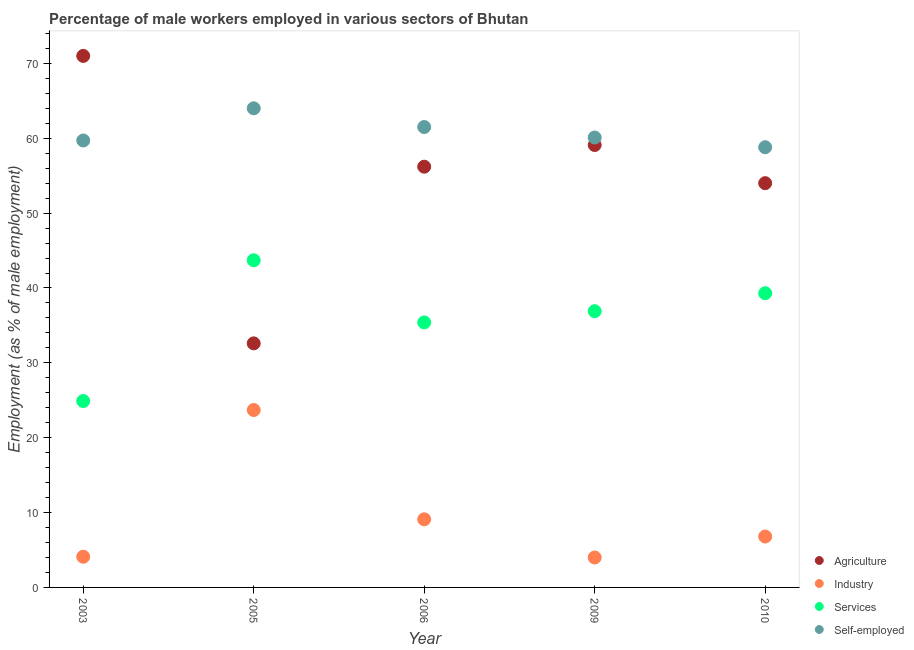What is the percentage of male workers in industry in 2005?
Provide a succinct answer. 23.7. Across all years, what is the maximum percentage of male workers in services?
Provide a short and direct response. 43.7. Across all years, what is the minimum percentage of male workers in agriculture?
Your answer should be compact. 32.6. In which year was the percentage of male workers in industry maximum?
Keep it short and to the point. 2005. What is the total percentage of self employed male workers in the graph?
Your answer should be very brief. 304.1. What is the difference between the percentage of male workers in services in 2009 and that in 2010?
Your answer should be very brief. -2.4. What is the difference between the percentage of male workers in services in 2006 and the percentage of male workers in industry in 2005?
Your answer should be compact. 11.7. What is the average percentage of male workers in industry per year?
Your answer should be compact. 9.54. In the year 2010, what is the difference between the percentage of male workers in agriculture and percentage of male workers in industry?
Your answer should be compact. 47.2. What is the ratio of the percentage of self employed male workers in 2003 to that in 2009?
Keep it short and to the point. 0.99. What is the difference between the highest and the second highest percentage of male workers in services?
Provide a short and direct response. 4.4. What is the difference between the highest and the lowest percentage of male workers in industry?
Provide a short and direct response. 19.7. Is it the case that in every year, the sum of the percentage of male workers in agriculture and percentage of male workers in industry is greater than the percentage of male workers in services?
Give a very brief answer. Yes. Does the percentage of male workers in industry monotonically increase over the years?
Your answer should be compact. No. Is the percentage of self employed male workers strictly less than the percentage of male workers in services over the years?
Provide a short and direct response. No. How many dotlines are there?
Offer a terse response. 4. Are the values on the major ticks of Y-axis written in scientific E-notation?
Keep it short and to the point. No. Where does the legend appear in the graph?
Ensure brevity in your answer.  Bottom right. What is the title of the graph?
Your answer should be very brief. Percentage of male workers employed in various sectors of Bhutan. Does "Self-employed" appear as one of the legend labels in the graph?
Ensure brevity in your answer.  Yes. What is the label or title of the Y-axis?
Give a very brief answer. Employment (as % of male employment). What is the Employment (as % of male employment) of Agriculture in 2003?
Offer a terse response. 71. What is the Employment (as % of male employment) in Industry in 2003?
Your response must be concise. 4.1. What is the Employment (as % of male employment) of Services in 2003?
Give a very brief answer. 24.9. What is the Employment (as % of male employment) of Self-employed in 2003?
Make the answer very short. 59.7. What is the Employment (as % of male employment) in Agriculture in 2005?
Keep it short and to the point. 32.6. What is the Employment (as % of male employment) in Industry in 2005?
Offer a terse response. 23.7. What is the Employment (as % of male employment) of Services in 2005?
Offer a terse response. 43.7. What is the Employment (as % of male employment) in Agriculture in 2006?
Make the answer very short. 56.2. What is the Employment (as % of male employment) of Industry in 2006?
Provide a short and direct response. 9.1. What is the Employment (as % of male employment) in Services in 2006?
Make the answer very short. 35.4. What is the Employment (as % of male employment) in Self-employed in 2006?
Your answer should be very brief. 61.5. What is the Employment (as % of male employment) of Agriculture in 2009?
Your answer should be compact. 59.1. What is the Employment (as % of male employment) of Services in 2009?
Keep it short and to the point. 36.9. What is the Employment (as % of male employment) of Self-employed in 2009?
Offer a terse response. 60.1. What is the Employment (as % of male employment) in Agriculture in 2010?
Offer a very short reply. 54. What is the Employment (as % of male employment) in Industry in 2010?
Offer a very short reply. 6.8. What is the Employment (as % of male employment) in Services in 2010?
Ensure brevity in your answer.  39.3. What is the Employment (as % of male employment) in Self-employed in 2010?
Provide a succinct answer. 58.8. Across all years, what is the maximum Employment (as % of male employment) of Agriculture?
Offer a terse response. 71. Across all years, what is the maximum Employment (as % of male employment) of Industry?
Make the answer very short. 23.7. Across all years, what is the maximum Employment (as % of male employment) of Services?
Keep it short and to the point. 43.7. Across all years, what is the maximum Employment (as % of male employment) of Self-employed?
Offer a very short reply. 64. Across all years, what is the minimum Employment (as % of male employment) of Agriculture?
Offer a very short reply. 32.6. Across all years, what is the minimum Employment (as % of male employment) of Industry?
Keep it short and to the point. 4. Across all years, what is the minimum Employment (as % of male employment) in Services?
Your answer should be very brief. 24.9. Across all years, what is the minimum Employment (as % of male employment) in Self-employed?
Your answer should be very brief. 58.8. What is the total Employment (as % of male employment) in Agriculture in the graph?
Offer a very short reply. 272.9. What is the total Employment (as % of male employment) of Industry in the graph?
Keep it short and to the point. 47.7. What is the total Employment (as % of male employment) in Services in the graph?
Your answer should be very brief. 180.2. What is the total Employment (as % of male employment) in Self-employed in the graph?
Offer a terse response. 304.1. What is the difference between the Employment (as % of male employment) in Agriculture in 2003 and that in 2005?
Provide a short and direct response. 38.4. What is the difference between the Employment (as % of male employment) in Industry in 2003 and that in 2005?
Make the answer very short. -19.6. What is the difference between the Employment (as % of male employment) of Services in 2003 and that in 2005?
Provide a short and direct response. -18.8. What is the difference between the Employment (as % of male employment) of Agriculture in 2003 and that in 2006?
Provide a short and direct response. 14.8. What is the difference between the Employment (as % of male employment) of Self-employed in 2003 and that in 2006?
Your answer should be compact. -1.8. What is the difference between the Employment (as % of male employment) of Self-employed in 2003 and that in 2009?
Make the answer very short. -0.4. What is the difference between the Employment (as % of male employment) of Industry in 2003 and that in 2010?
Make the answer very short. -2.7. What is the difference between the Employment (as % of male employment) of Services in 2003 and that in 2010?
Make the answer very short. -14.4. What is the difference between the Employment (as % of male employment) in Agriculture in 2005 and that in 2006?
Provide a short and direct response. -23.6. What is the difference between the Employment (as % of male employment) in Industry in 2005 and that in 2006?
Offer a terse response. 14.6. What is the difference between the Employment (as % of male employment) of Agriculture in 2005 and that in 2009?
Offer a terse response. -26.5. What is the difference between the Employment (as % of male employment) in Industry in 2005 and that in 2009?
Keep it short and to the point. 19.7. What is the difference between the Employment (as % of male employment) of Services in 2005 and that in 2009?
Make the answer very short. 6.8. What is the difference between the Employment (as % of male employment) in Self-employed in 2005 and that in 2009?
Your answer should be compact. 3.9. What is the difference between the Employment (as % of male employment) in Agriculture in 2005 and that in 2010?
Make the answer very short. -21.4. What is the difference between the Employment (as % of male employment) of Industry in 2005 and that in 2010?
Your answer should be very brief. 16.9. What is the difference between the Employment (as % of male employment) in Self-employed in 2005 and that in 2010?
Ensure brevity in your answer.  5.2. What is the difference between the Employment (as % of male employment) in Industry in 2006 and that in 2009?
Your answer should be compact. 5.1. What is the difference between the Employment (as % of male employment) in Services in 2006 and that in 2009?
Keep it short and to the point. -1.5. What is the difference between the Employment (as % of male employment) in Agriculture in 2006 and that in 2010?
Make the answer very short. 2.2. What is the difference between the Employment (as % of male employment) of Services in 2006 and that in 2010?
Give a very brief answer. -3.9. What is the difference between the Employment (as % of male employment) of Agriculture in 2009 and that in 2010?
Offer a terse response. 5.1. What is the difference between the Employment (as % of male employment) in Industry in 2009 and that in 2010?
Keep it short and to the point. -2.8. What is the difference between the Employment (as % of male employment) of Services in 2009 and that in 2010?
Your response must be concise. -2.4. What is the difference between the Employment (as % of male employment) in Self-employed in 2009 and that in 2010?
Your answer should be compact. 1.3. What is the difference between the Employment (as % of male employment) of Agriculture in 2003 and the Employment (as % of male employment) of Industry in 2005?
Ensure brevity in your answer.  47.3. What is the difference between the Employment (as % of male employment) in Agriculture in 2003 and the Employment (as % of male employment) in Services in 2005?
Your answer should be compact. 27.3. What is the difference between the Employment (as % of male employment) of Industry in 2003 and the Employment (as % of male employment) of Services in 2005?
Give a very brief answer. -39.6. What is the difference between the Employment (as % of male employment) in Industry in 2003 and the Employment (as % of male employment) in Self-employed in 2005?
Make the answer very short. -59.9. What is the difference between the Employment (as % of male employment) of Services in 2003 and the Employment (as % of male employment) of Self-employed in 2005?
Provide a succinct answer. -39.1. What is the difference between the Employment (as % of male employment) of Agriculture in 2003 and the Employment (as % of male employment) of Industry in 2006?
Your answer should be compact. 61.9. What is the difference between the Employment (as % of male employment) in Agriculture in 2003 and the Employment (as % of male employment) in Services in 2006?
Your answer should be very brief. 35.6. What is the difference between the Employment (as % of male employment) in Agriculture in 2003 and the Employment (as % of male employment) in Self-employed in 2006?
Offer a terse response. 9.5. What is the difference between the Employment (as % of male employment) in Industry in 2003 and the Employment (as % of male employment) in Services in 2006?
Your response must be concise. -31.3. What is the difference between the Employment (as % of male employment) in Industry in 2003 and the Employment (as % of male employment) in Self-employed in 2006?
Your answer should be very brief. -57.4. What is the difference between the Employment (as % of male employment) of Services in 2003 and the Employment (as % of male employment) of Self-employed in 2006?
Offer a terse response. -36.6. What is the difference between the Employment (as % of male employment) of Agriculture in 2003 and the Employment (as % of male employment) of Services in 2009?
Make the answer very short. 34.1. What is the difference between the Employment (as % of male employment) in Agriculture in 2003 and the Employment (as % of male employment) in Self-employed in 2009?
Offer a terse response. 10.9. What is the difference between the Employment (as % of male employment) of Industry in 2003 and the Employment (as % of male employment) of Services in 2009?
Offer a terse response. -32.8. What is the difference between the Employment (as % of male employment) in Industry in 2003 and the Employment (as % of male employment) in Self-employed in 2009?
Your response must be concise. -56. What is the difference between the Employment (as % of male employment) in Services in 2003 and the Employment (as % of male employment) in Self-employed in 2009?
Offer a terse response. -35.2. What is the difference between the Employment (as % of male employment) of Agriculture in 2003 and the Employment (as % of male employment) of Industry in 2010?
Your answer should be compact. 64.2. What is the difference between the Employment (as % of male employment) in Agriculture in 2003 and the Employment (as % of male employment) in Services in 2010?
Your answer should be compact. 31.7. What is the difference between the Employment (as % of male employment) in Agriculture in 2003 and the Employment (as % of male employment) in Self-employed in 2010?
Make the answer very short. 12.2. What is the difference between the Employment (as % of male employment) of Industry in 2003 and the Employment (as % of male employment) of Services in 2010?
Offer a very short reply. -35.2. What is the difference between the Employment (as % of male employment) in Industry in 2003 and the Employment (as % of male employment) in Self-employed in 2010?
Your response must be concise. -54.7. What is the difference between the Employment (as % of male employment) of Services in 2003 and the Employment (as % of male employment) of Self-employed in 2010?
Your answer should be compact. -33.9. What is the difference between the Employment (as % of male employment) in Agriculture in 2005 and the Employment (as % of male employment) in Industry in 2006?
Your answer should be very brief. 23.5. What is the difference between the Employment (as % of male employment) of Agriculture in 2005 and the Employment (as % of male employment) of Self-employed in 2006?
Provide a succinct answer. -28.9. What is the difference between the Employment (as % of male employment) in Industry in 2005 and the Employment (as % of male employment) in Services in 2006?
Offer a very short reply. -11.7. What is the difference between the Employment (as % of male employment) of Industry in 2005 and the Employment (as % of male employment) of Self-employed in 2006?
Offer a very short reply. -37.8. What is the difference between the Employment (as % of male employment) in Services in 2005 and the Employment (as % of male employment) in Self-employed in 2006?
Your answer should be compact. -17.8. What is the difference between the Employment (as % of male employment) of Agriculture in 2005 and the Employment (as % of male employment) of Industry in 2009?
Keep it short and to the point. 28.6. What is the difference between the Employment (as % of male employment) in Agriculture in 2005 and the Employment (as % of male employment) in Self-employed in 2009?
Give a very brief answer. -27.5. What is the difference between the Employment (as % of male employment) in Industry in 2005 and the Employment (as % of male employment) in Services in 2009?
Give a very brief answer. -13.2. What is the difference between the Employment (as % of male employment) in Industry in 2005 and the Employment (as % of male employment) in Self-employed in 2009?
Your response must be concise. -36.4. What is the difference between the Employment (as % of male employment) in Services in 2005 and the Employment (as % of male employment) in Self-employed in 2009?
Offer a terse response. -16.4. What is the difference between the Employment (as % of male employment) in Agriculture in 2005 and the Employment (as % of male employment) in Industry in 2010?
Ensure brevity in your answer.  25.8. What is the difference between the Employment (as % of male employment) of Agriculture in 2005 and the Employment (as % of male employment) of Self-employed in 2010?
Offer a terse response. -26.2. What is the difference between the Employment (as % of male employment) of Industry in 2005 and the Employment (as % of male employment) of Services in 2010?
Ensure brevity in your answer.  -15.6. What is the difference between the Employment (as % of male employment) in Industry in 2005 and the Employment (as % of male employment) in Self-employed in 2010?
Give a very brief answer. -35.1. What is the difference between the Employment (as % of male employment) in Services in 2005 and the Employment (as % of male employment) in Self-employed in 2010?
Offer a terse response. -15.1. What is the difference between the Employment (as % of male employment) in Agriculture in 2006 and the Employment (as % of male employment) in Industry in 2009?
Ensure brevity in your answer.  52.2. What is the difference between the Employment (as % of male employment) of Agriculture in 2006 and the Employment (as % of male employment) of Services in 2009?
Offer a terse response. 19.3. What is the difference between the Employment (as % of male employment) of Agriculture in 2006 and the Employment (as % of male employment) of Self-employed in 2009?
Your answer should be compact. -3.9. What is the difference between the Employment (as % of male employment) of Industry in 2006 and the Employment (as % of male employment) of Services in 2009?
Give a very brief answer. -27.8. What is the difference between the Employment (as % of male employment) in Industry in 2006 and the Employment (as % of male employment) in Self-employed in 2009?
Ensure brevity in your answer.  -51. What is the difference between the Employment (as % of male employment) in Services in 2006 and the Employment (as % of male employment) in Self-employed in 2009?
Offer a very short reply. -24.7. What is the difference between the Employment (as % of male employment) in Agriculture in 2006 and the Employment (as % of male employment) in Industry in 2010?
Your response must be concise. 49.4. What is the difference between the Employment (as % of male employment) in Agriculture in 2006 and the Employment (as % of male employment) in Services in 2010?
Your answer should be compact. 16.9. What is the difference between the Employment (as % of male employment) of Industry in 2006 and the Employment (as % of male employment) of Services in 2010?
Your response must be concise. -30.2. What is the difference between the Employment (as % of male employment) in Industry in 2006 and the Employment (as % of male employment) in Self-employed in 2010?
Your answer should be compact. -49.7. What is the difference between the Employment (as % of male employment) of Services in 2006 and the Employment (as % of male employment) of Self-employed in 2010?
Provide a short and direct response. -23.4. What is the difference between the Employment (as % of male employment) of Agriculture in 2009 and the Employment (as % of male employment) of Industry in 2010?
Offer a terse response. 52.3. What is the difference between the Employment (as % of male employment) of Agriculture in 2009 and the Employment (as % of male employment) of Services in 2010?
Offer a terse response. 19.8. What is the difference between the Employment (as % of male employment) of Industry in 2009 and the Employment (as % of male employment) of Services in 2010?
Your response must be concise. -35.3. What is the difference between the Employment (as % of male employment) of Industry in 2009 and the Employment (as % of male employment) of Self-employed in 2010?
Give a very brief answer. -54.8. What is the difference between the Employment (as % of male employment) of Services in 2009 and the Employment (as % of male employment) of Self-employed in 2010?
Your answer should be compact. -21.9. What is the average Employment (as % of male employment) of Agriculture per year?
Offer a very short reply. 54.58. What is the average Employment (as % of male employment) in Industry per year?
Keep it short and to the point. 9.54. What is the average Employment (as % of male employment) of Services per year?
Ensure brevity in your answer.  36.04. What is the average Employment (as % of male employment) in Self-employed per year?
Keep it short and to the point. 60.82. In the year 2003, what is the difference between the Employment (as % of male employment) in Agriculture and Employment (as % of male employment) in Industry?
Offer a terse response. 66.9. In the year 2003, what is the difference between the Employment (as % of male employment) of Agriculture and Employment (as % of male employment) of Services?
Offer a terse response. 46.1. In the year 2003, what is the difference between the Employment (as % of male employment) in Agriculture and Employment (as % of male employment) in Self-employed?
Offer a terse response. 11.3. In the year 2003, what is the difference between the Employment (as % of male employment) of Industry and Employment (as % of male employment) of Services?
Provide a succinct answer. -20.8. In the year 2003, what is the difference between the Employment (as % of male employment) in Industry and Employment (as % of male employment) in Self-employed?
Keep it short and to the point. -55.6. In the year 2003, what is the difference between the Employment (as % of male employment) of Services and Employment (as % of male employment) of Self-employed?
Keep it short and to the point. -34.8. In the year 2005, what is the difference between the Employment (as % of male employment) of Agriculture and Employment (as % of male employment) of Self-employed?
Your answer should be very brief. -31.4. In the year 2005, what is the difference between the Employment (as % of male employment) of Industry and Employment (as % of male employment) of Self-employed?
Provide a short and direct response. -40.3. In the year 2005, what is the difference between the Employment (as % of male employment) of Services and Employment (as % of male employment) of Self-employed?
Make the answer very short. -20.3. In the year 2006, what is the difference between the Employment (as % of male employment) in Agriculture and Employment (as % of male employment) in Industry?
Ensure brevity in your answer.  47.1. In the year 2006, what is the difference between the Employment (as % of male employment) in Agriculture and Employment (as % of male employment) in Services?
Offer a very short reply. 20.8. In the year 2006, what is the difference between the Employment (as % of male employment) in Agriculture and Employment (as % of male employment) in Self-employed?
Keep it short and to the point. -5.3. In the year 2006, what is the difference between the Employment (as % of male employment) in Industry and Employment (as % of male employment) in Services?
Give a very brief answer. -26.3. In the year 2006, what is the difference between the Employment (as % of male employment) of Industry and Employment (as % of male employment) of Self-employed?
Give a very brief answer. -52.4. In the year 2006, what is the difference between the Employment (as % of male employment) in Services and Employment (as % of male employment) in Self-employed?
Ensure brevity in your answer.  -26.1. In the year 2009, what is the difference between the Employment (as % of male employment) of Agriculture and Employment (as % of male employment) of Industry?
Ensure brevity in your answer.  55.1. In the year 2009, what is the difference between the Employment (as % of male employment) in Industry and Employment (as % of male employment) in Services?
Your answer should be compact. -32.9. In the year 2009, what is the difference between the Employment (as % of male employment) in Industry and Employment (as % of male employment) in Self-employed?
Give a very brief answer. -56.1. In the year 2009, what is the difference between the Employment (as % of male employment) in Services and Employment (as % of male employment) in Self-employed?
Give a very brief answer. -23.2. In the year 2010, what is the difference between the Employment (as % of male employment) of Agriculture and Employment (as % of male employment) of Industry?
Your answer should be very brief. 47.2. In the year 2010, what is the difference between the Employment (as % of male employment) in Industry and Employment (as % of male employment) in Services?
Make the answer very short. -32.5. In the year 2010, what is the difference between the Employment (as % of male employment) in Industry and Employment (as % of male employment) in Self-employed?
Keep it short and to the point. -52. In the year 2010, what is the difference between the Employment (as % of male employment) in Services and Employment (as % of male employment) in Self-employed?
Ensure brevity in your answer.  -19.5. What is the ratio of the Employment (as % of male employment) in Agriculture in 2003 to that in 2005?
Provide a succinct answer. 2.18. What is the ratio of the Employment (as % of male employment) in Industry in 2003 to that in 2005?
Give a very brief answer. 0.17. What is the ratio of the Employment (as % of male employment) of Services in 2003 to that in 2005?
Offer a very short reply. 0.57. What is the ratio of the Employment (as % of male employment) in Self-employed in 2003 to that in 2005?
Make the answer very short. 0.93. What is the ratio of the Employment (as % of male employment) of Agriculture in 2003 to that in 2006?
Offer a very short reply. 1.26. What is the ratio of the Employment (as % of male employment) of Industry in 2003 to that in 2006?
Your response must be concise. 0.45. What is the ratio of the Employment (as % of male employment) of Services in 2003 to that in 2006?
Keep it short and to the point. 0.7. What is the ratio of the Employment (as % of male employment) in Self-employed in 2003 to that in 2006?
Your response must be concise. 0.97. What is the ratio of the Employment (as % of male employment) in Agriculture in 2003 to that in 2009?
Give a very brief answer. 1.2. What is the ratio of the Employment (as % of male employment) of Services in 2003 to that in 2009?
Your answer should be very brief. 0.67. What is the ratio of the Employment (as % of male employment) of Self-employed in 2003 to that in 2009?
Ensure brevity in your answer.  0.99. What is the ratio of the Employment (as % of male employment) in Agriculture in 2003 to that in 2010?
Make the answer very short. 1.31. What is the ratio of the Employment (as % of male employment) of Industry in 2003 to that in 2010?
Your answer should be very brief. 0.6. What is the ratio of the Employment (as % of male employment) of Services in 2003 to that in 2010?
Offer a terse response. 0.63. What is the ratio of the Employment (as % of male employment) in Self-employed in 2003 to that in 2010?
Make the answer very short. 1.02. What is the ratio of the Employment (as % of male employment) in Agriculture in 2005 to that in 2006?
Provide a short and direct response. 0.58. What is the ratio of the Employment (as % of male employment) of Industry in 2005 to that in 2006?
Provide a succinct answer. 2.6. What is the ratio of the Employment (as % of male employment) of Services in 2005 to that in 2006?
Your response must be concise. 1.23. What is the ratio of the Employment (as % of male employment) in Self-employed in 2005 to that in 2006?
Keep it short and to the point. 1.04. What is the ratio of the Employment (as % of male employment) of Agriculture in 2005 to that in 2009?
Your answer should be compact. 0.55. What is the ratio of the Employment (as % of male employment) of Industry in 2005 to that in 2009?
Your answer should be very brief. 5.92. What is the ratio of the Employment (as % of male employment) of Services in 2005 to that in 2009?
Your answer should be very brief. 1.18. What is the ratio of the Employment (as % of male employment) in Self-employed in 2005 to that in 2009?
Offer a terse response. 1.06. What is the ratio of the Employment (as % of male employment) in Agriculture in 2005 to that in 2010?
Offer a very short reply. 0.6. What is the ratio of the Employment (as % of male employment) of Industry in 2005 to that in 2010?
Ensure brevity in your answer.  3.49. What is the ratio of the Employment (as % of male employment) of Services in 2005 to that in 2010?
Provide a short and direct response. 1.11. What is the ratio of the Employment (as % of male employment) in Self-employed in 2005 to that in 2010?
Ensure brevity in your answer.  1.09. What is the ratio of the Employment (as % of male employment) of Agriculture in 2006 to that in 2009?
Make the answer very short. 0.95. What is the ratio of the Employment (as % of male employment) in Industry in 2006 to that in 2009?
Keep it short and to the point. 2.27. What is the ratio of the Employment (as % of male employment) of Services in 2006 to that in 2009?
Your response must be concise. 0.96. What is the ratio of the Employment (as % of male employment) of Self-employed in 2006 to that in 2009?
Give a very brief answer. 1.02. What is the ratio of the Employment (as % of male employment) in Agriculture in 2006 to that in 2010?
Make the answer very short. 1.04. What is the ratio of the Employment (as % of male employment) of Industry in 2006 to that in 2010?
Provide a short and direct response. 1.34. What is the ratio of the Employment (as % of male employment) of Services in 2006 to that in 2010?
Your answer should be compact. 0.9. What is the ratio of the Employment (as % of male employment) of Self-employed in 2006 to that in 2010?
Provide a succinct answer. 1.05. What is the ratio of the Employment (as % of male employment) in Agriculture in 2009 to that in 2010?
Provide a succinct answer. 1.09. What is the ratio of the Employment (as % of male employment) of Industry in 2009 to that in 2010?
Your answer should be compact. 0.59. What is the ratio of the Employment (as % of male employment) of Services in 2009 to that in 2010?
Your answer should be very brief. 0.94. What is the ratio of the Employment (as % of male employment) in Self-employed in 2009 to that in 2010?
Your answer should be very brief. 1.02. What is the difference between the highest and the lowest Employment (as % of male employment) of Agriculture?
Your answer should be compact. 38.4. What is the difference between the highest and the lowest Employment (as % of male employment) in Industry?
Your answer should be very brief. 19.7. What is the difference between the highest and the lowest Employment (as % of male employment) in Self-employed?
Keep it short and to the point. 5.2. 